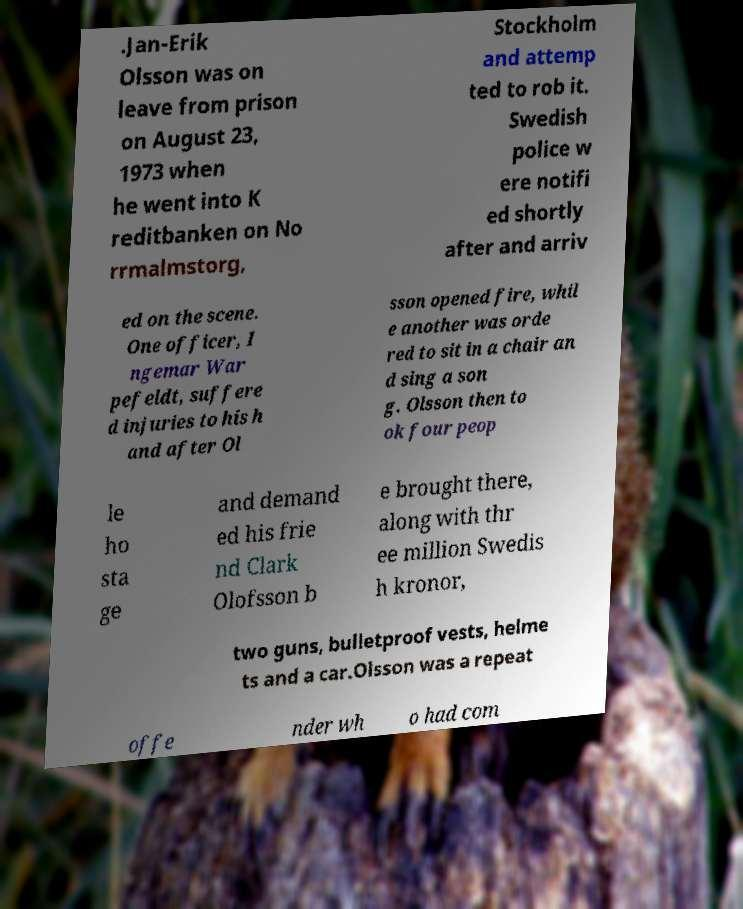Can you read and provide the text displayed in the image?This photo seems to have some interesting text. Can you extract and type it out for me? .Jan-Erik Olsson was on leave from prison on August 23, 1973 when he went into K reditbanken on No rrmalmstorg, Stockholm and attemp ted to rob it. Swedish police w ere notifi ed shortly after and arriv ed on the scene. One officer, I ngemar War pefeldt, suffere d injuries to his h and after Ol sson opened fire, whil e another was orde red to sit in a chair an d sing a son g. Olsson then to ok four peop le ho sta ge and demand ed his frie nd Clark Olofsson b e brought there, along with thr ee million Swedis h kronor, two guns, bulletproof vests, helme ts and a car.Olsson was a repeat offe nder wh o had com 